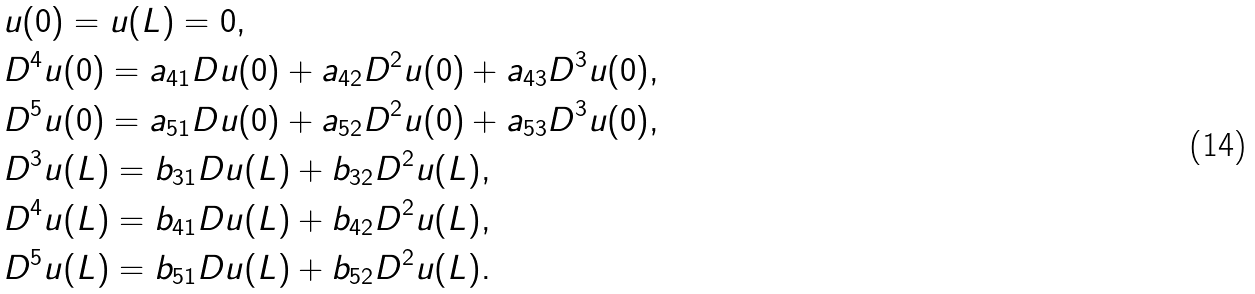<formula> <loc_0><loc_0><loc_500><loc_500>& u ( 0 ) = u ( L ) = 0 , \\ & D ^ { 4 } u ( 0 ) = a _ { 4 1 } D u ( 0 ) + a _ { 4 2 } D ^ { 2 } u ( 0 ) + a _ { 4 3 } D ^ { 3 } u ( 0 ) , \\ & D ^ { 5 } u ( 0 ) = a _ { 5 1 } D u ( 0 ) + a _ { 5 2 } D ^ { 2 } u ( 0 ) + a _ { 5 3 } D ^ { 3 } u ( 0 ) , \\ & D ^ { 3 } u ( L ) = b _ { 3 1 } D u ( L ) + b _ { 3 2 } D ^ { 2 } u ( L ) , \\ & D ^ { 4 } u ( L ) = b _ { 4 1 } D u ( L ) + b _ { 4 2 } D ^ { 2 } u ( L ) , \\ & D ^ { 5 } u ( L ) = b _ { 5 1 } D u ( L ) + b _ { 5 2 } D ^ { 2 } u ( L ) .</formula> 